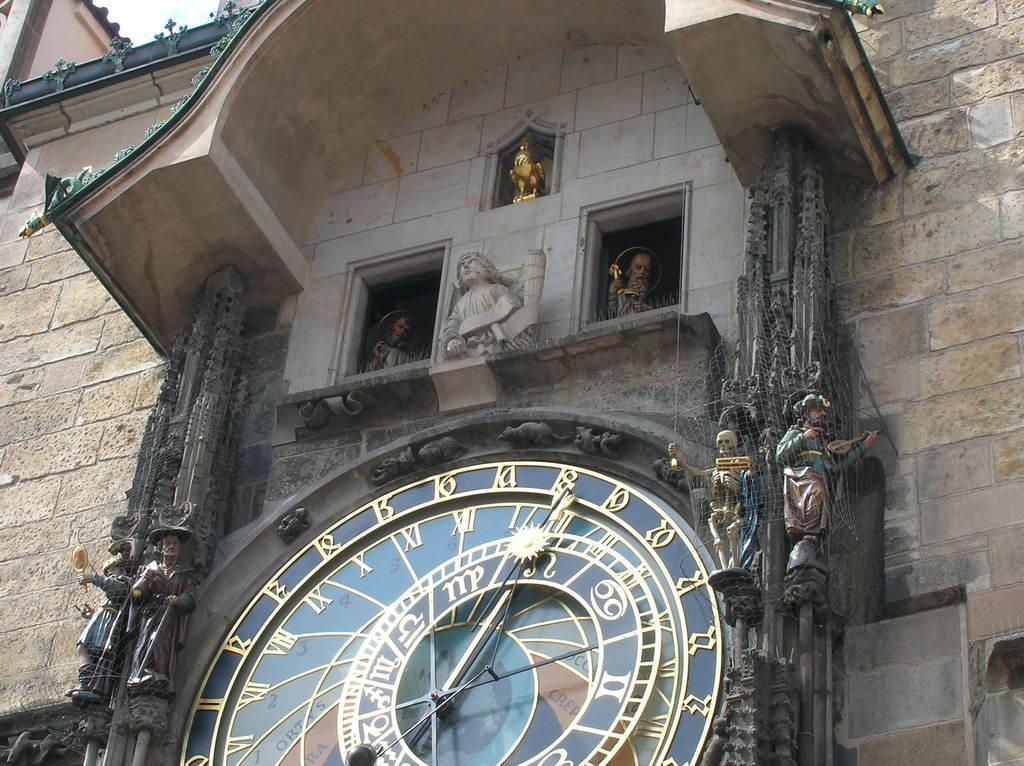Can you describe this image briefly? In the picture we can see a historical building with some sculptures to the wall and a clock which is designed. 